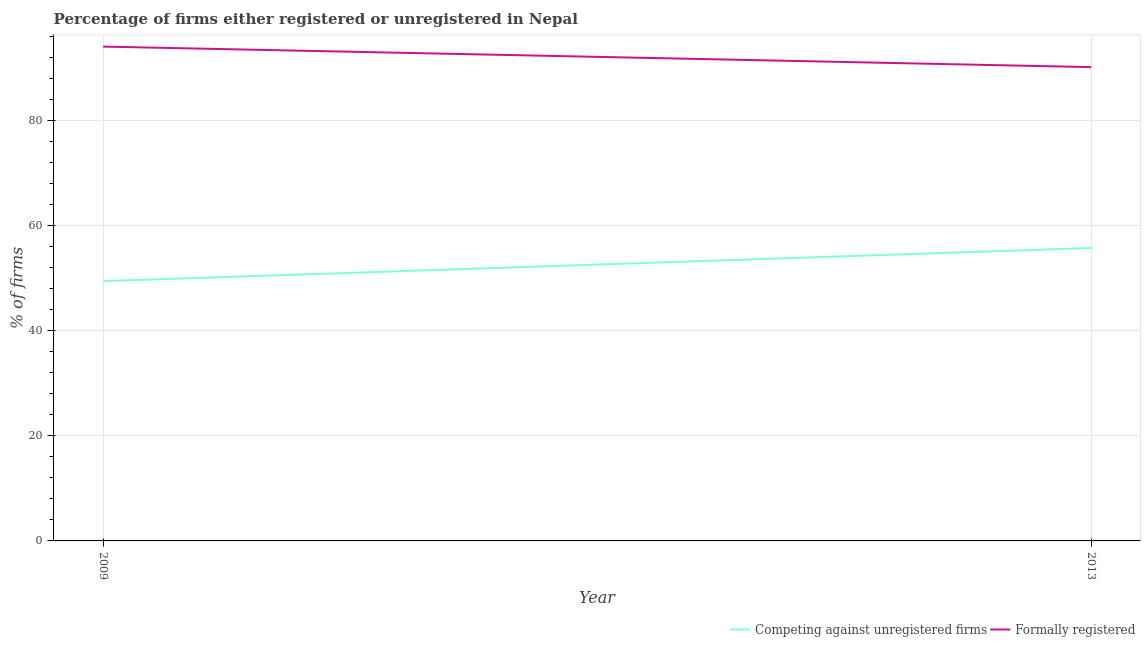Does the line corresponding to percentage of registered firms intersect with the line corresponding to percentage of formally registered firms?
Offer a terse response. No. Is the number of lines equal to the number of legend labels?
Your answer should be very brief. Yes. What is the percentage of formally registered firms in 2009?
Your answer should be very brief. 94. Across all years, what is the maximum percentage of formally registered firms?
Your response must be concise. 94. Across all years, what is the minimum percentage of registered firms?
Your answer should be compact. 49.4. What is the total percentage of formally registered firms in the graph?
Make the answer very short. 184.1. What is the difference between the percentage of formally registered firms in 2009 and that in 2013?
Your answer should be very brief. 3.9. What is the difference between the percentage of formally registered firms in 2009 and the percentage of registered firms in 2013?
Provide a short and direct response. 38.3. What is the average percentage of formally registered firms per year?
Provide a succinct answer. 92.05. In the year 2009, what is the difference between the percentage of registered firms and percentage of formally registered firms?
Your answer should be very brief. -44.6. In how many years, is the percentage of registered firms greater than 80 %?
Make the answer very short. 0. What is the ratio of the percentage of registered firms in 2009 to that in 2013?
Make the answer very short. 0.89. Is the percentage of registered firms in 2009 less than that in 2013?
Provide a succinct answer. Yes. How many years are there in the graph?
Your answer should be very brief. 2. Does the graph contain any zero values?
Ensure brevity in your answer.  No. How are the legend labels stacked?
Keep it short and to the point. Horizontal. What is the title of the graph?
Ensure brevity in your answer.  Percentage of firms either registered or unregistered in Nepal. What is the label or title of the X-axis?
Provide a short and direct response. Year. What is the label or title of the Y-axis?
Keep it short and to the point. % of firms. What is the % of firms in Competing against unregistered firms in 2009?
Provide a short and direct response. 49.4. What is the % of firms in Formally registered in 2009?
Give a very brief answer. 94. What is the % of firms of Competing against unregistered firms in 2013?
Your answer should be compact. 55.7. What is the % of firms in Formally registered in 2013?
Your answer should be compact. 90.1. Across all years, what is the maximum % of firms of Competing against unregistered firms?
Your response must be concise. 55.7. Across all years, what is the maximum % of firms in Formally registered?
Your response must be concise. 94. Across all years, what is the minimum % of firms of Competing against unregistered firms?
Ensure brevity in your answer.  49.4. Across all years, what is the minimum % of firms in Formally registered?
Provide a succinct answer. 90.1. What is the total % of firms of Competing against unregistered firms in the graph?
Your answer should be compact. 105.1. What is the total % of firms in Formally registered in the graph?
Offer a very short reply. 184.1. What is the difference between the % of firms in Competing against unregistered firms in 2009 and that in 2013?
Offer a terse response. -6.3. What is the difference between the % of firms in Competing against unregistered firms in 2009 and the % of firms in Formally registered in 2013?
Your answer should be compact. -40.7. What is the average % of firms in Competing against unregistered firms per year?
Offer a terse response. 52.55. What is the average % of firms of Formally registered per year?
Offer a terse response. 92.05. In the year 2009, what is the difference between the % of firms in Competing against unregistered firms and % of firms in Formally registered?
Your response must be concise. -44.6. In the year 2013, what is the difference between the % of firms in Competing against unregistered firms and % of firms in Formally registered?
Your answer should be compact. -34.4. What is the ratio of the % of firms of Competing against unregistered firms in 2009 to that in 2013?
Offer a very short reply. 0.89. What is the ratio of the % of firms in Formally registered in 2009 to that in 2013?
Your answer should be compact. 1.04. What is the difference between the highest and the second highest % of firms of Competing against unregistered firms?
Your answer should be compact. 6.3. What is the difference between the highest and the second highest % of firms of Formally registered?
Make the answer very short. 3.9. 